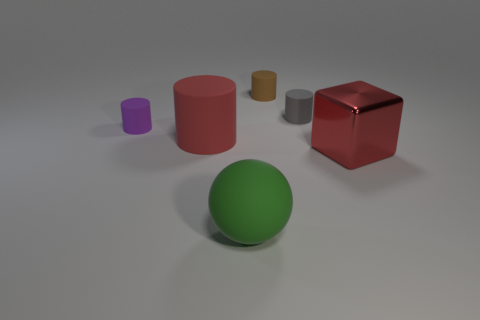What number of other things are there of the same color as the shiny thing?
Make the answer very short. 1. Is the color of the big object right of the big green object the same as the ball?
Provide a succinct answer. No. How many green things are rubber spheres or large shiny cubes?
Your response must be concise. 1. Is there anything else that is made of the same material as the tiny purple cylinder?
Provide a succinct answer. Yes. Do the large thing right of the big green sphere and the red cylinder have the same material?
Your answer should be very brief. No. How many things are either tiny green shiny things or large green objects on the left side of the tiny brown thing?
Your answer should be compact. 1. What number of small purple rubber things are right of the small object left of the big matte object in front of the big cylinder?
Provide a short and direct response. 0. Do the big rubber object that is left of the green matte sphere and the brown thing have the same shape?
Your answer should be compact. Yes. There is a tiny rubber thing to the right of the brown object; is there a small gray thing behind it?
Offer a terse response. No. How many small cyan metal things are there?
Offer a terse response. 0. 